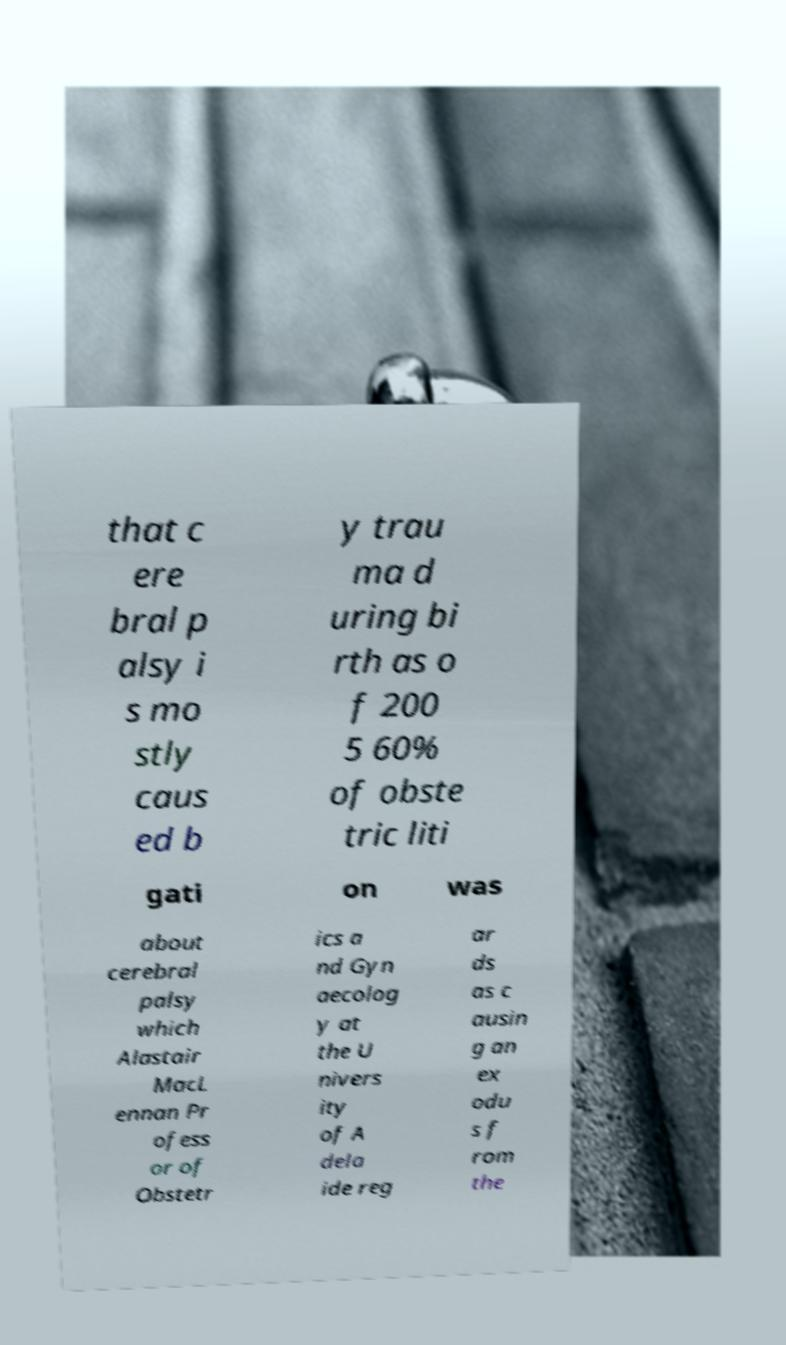There's text embedded in this image that I need extracted. Can you transcribe it verbatim? that c ere bral p alsy i s mo stly caus ed b y trau ma d uring bi rth as o f 200 5 60% of obste tric liti gati on was about cerebral palsy which Alastair MacL ennan Pr ofess or of Obstetr ics a nd Gyn aecolog y at the U nivers ity of A dela ide reg ar ds as c ausin g an ex odu s f rom the 